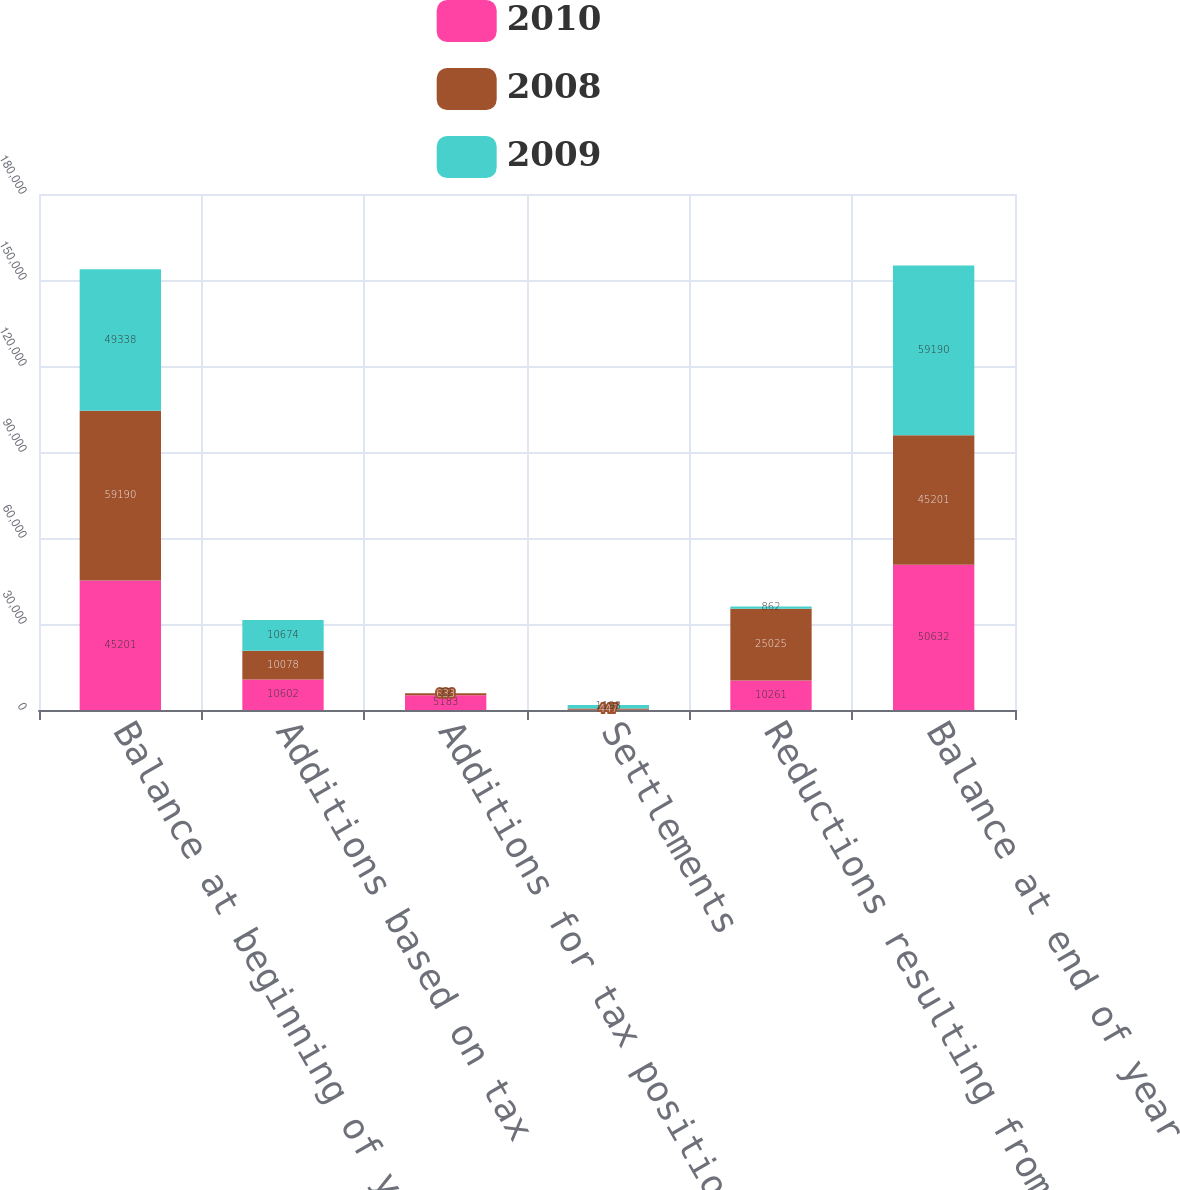Convert chart. <chart><loc_0><loc_0><loc_500><loc_500><stacked_bar_chart><ecel><fcel>Balance at beginning of year<fcel>Additions based on tax<fcel>Additions for tax positions of<fcel>Settlements<fcel>Reductions resulting from a<fcel>Balance at end of year<nl><fcel>2010<fcel>45201<fcel>10602<fcel>5183<fcel>93<fcel>10261<fcel>50632<nl><fcel>2008<fcel>59190<fcel>10078<fcel>633<fcel>447<fcel>25025<fcel>45201<nl><fcel>2009<fcel>49338<fcel>10674<fcel>22<fcel>1198<fcel>862<fcel>59190<nl></chart> 